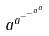<formula> <loc_0><loc_0><loc_500><loc_500>a ^ { a ^ { - ^ { - ^ { a ^ { a } } } } }</formula> 